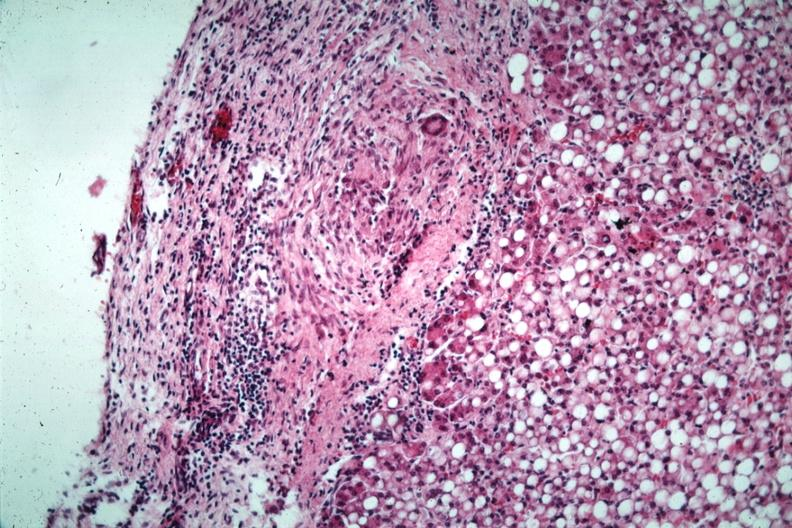what capsule quite good liver has marked fatty change?
Answer the question using a single word or phrase. Liver with tuberculoid granuloma in glissons 